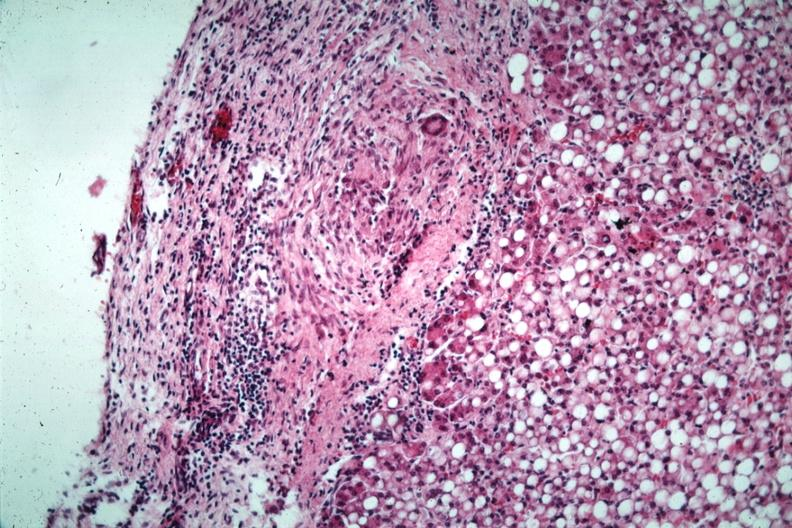what capsule quite good liver has marked fatty change?
Answer the question using a single word or phrase. Liver with tuberculoid granuloma in glissons 